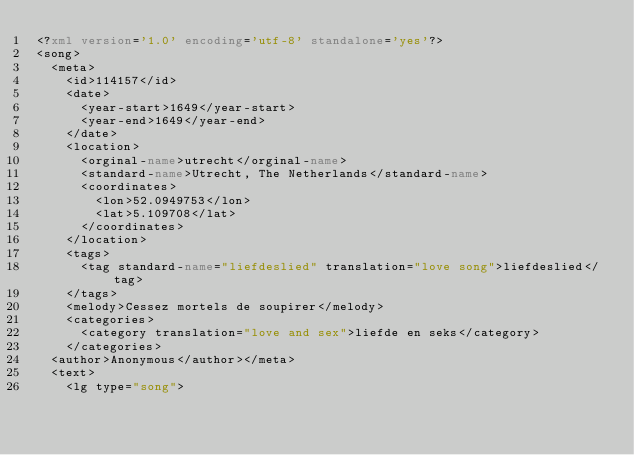Convert code to text. <code><loc_0><loc_0><loc_500><loc_500><_XML_><?xml version='1.0' encoding='utf-8' standalone='yes'?>
<song>
  <meta>
    <id>114157</id>
    <date>
      <year-start>1649</year-start>
      <year-end>1649</year-end>
    </date>
    <location>
      <orginal-name>utrecht</orginal-name>
      <standard-name>Utrecht, The Netherlands</standard-name>
      <coordinates>
        <lon>52.0949753</lon>
        <lat>5.109708</lat>
      </coordinates>
    </location>
    <tags>
      <tag standard-name="liefdeslied" translation="love song">liefdeslied</tag>
    </tags>
    <melody>Cessez mortels de soupirer</melody>
    <categories>
      <category translation="love and sex">liefde en seks</category>
    </categories>
  <author>Anonymous</author></meta>
  <text>
    <lg type="song"></code> 